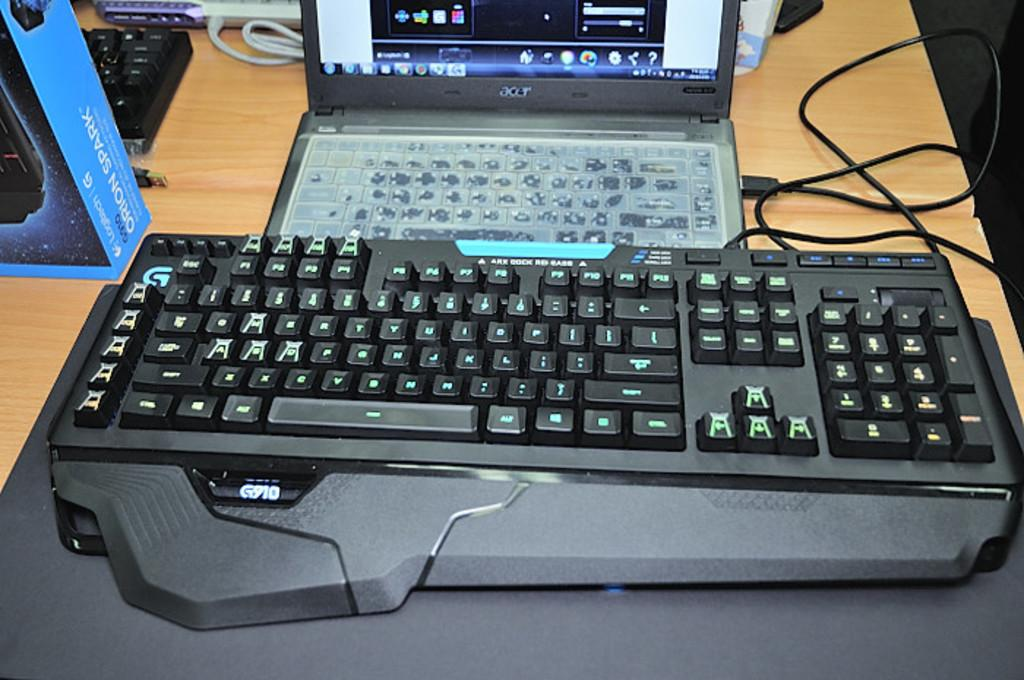Provide a one-sentence caption for the provided image. an Acer lap top computer attached to a larger G910 keyboard. 